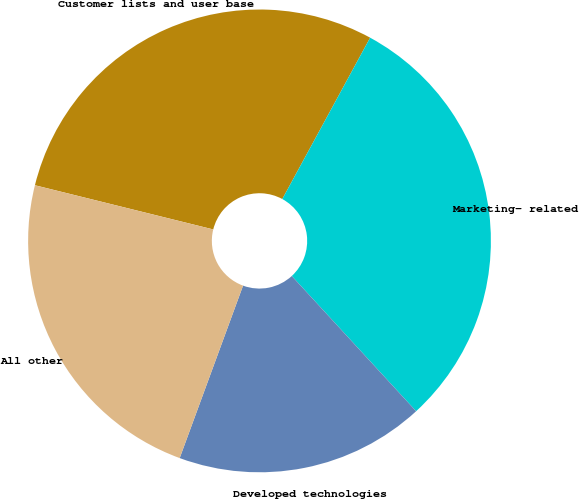Convert chart to OTSL. <chart><loc_0><loc_0><loc_500><loc_500><pie_chart><fcel>Customer lists and user base<fcel>Marketing- related<fcel>Developed technologies<fcel>All other<nl><fcel>29.07%<fcel>30.23%<fcel>17.44%<fcel>23.26%<nl></chart> 